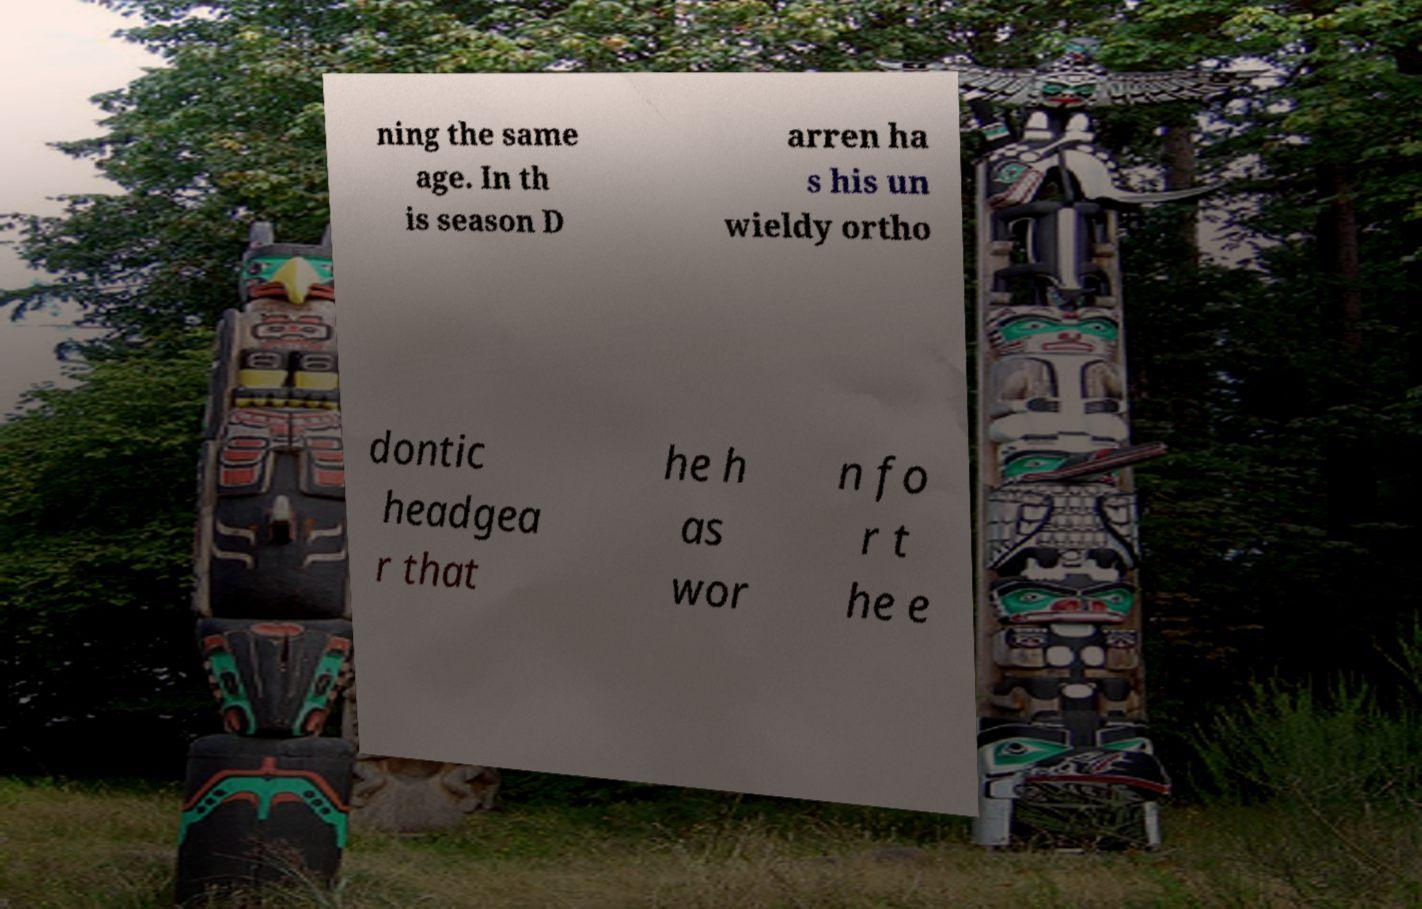There's text embedded in this image that I need extracted. Can you transcribe it verbatim? ning the same age. In th is season D arren ha s his un wieldy ortho dontic headgea r that he h as wor n fo r t he e 